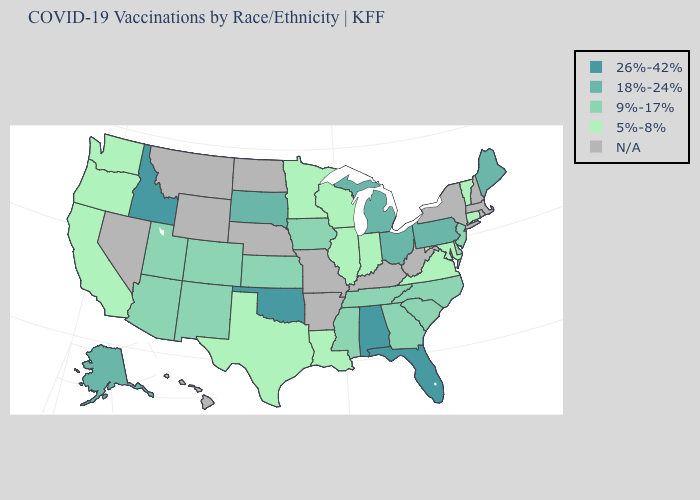How many symbols are there in the legend?
Concise answer only. 5. What is the value of Virginia?
Be succinct. 5%-8%. What is the value of Indiana?
Keep it brief. 5%-8%. Name the states that have a value in the range N/A?
Quick response, please. Arkansas, Hawaii, Kentucky, Massachusetts, Missouri, Montana, Nebraska, Nevada, New Hampshire, New York, North Dakota, Rhode Island, West Virginia, Wyoming. How many symbols are there in the legend?
Keep it brief. 5. What is the value of New Hampshire?
Concise answer only. N/A. Name the states that have a value in the range 9%-17%?
Give a very brief answer. Arizona, Colorado, Delaware, Georgia, Iowa, Kansas, Mississippi, New Jersey, New Mexico, North Carolina, South Carolina, Tennessee, Utah. What is the value of Missouri?
Short answer required. N/A. What is the value of Wyoming?
Keep it brief. N/A. Which states have the lowest value in the West?
Give a very brief answer. California, Oregon, Washington. Name the states that have a value in the range N/A?
Give a very brief answer. Arkansas, Hawaii, Kentucky, Massachusetts, Missouri, Montana, Nebraska, Nevada, New Hampshire, New York, North Dakota, Rhode Island, West Virginia, Wyoming. What is the value of South Carolina?
Give a very brief answer. 9%-17%. 